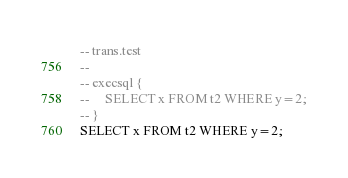<code> <loc_0><loc_0><loc_500><loc_500><_SQL_>-- trans.test
-- 
-- execsql {
--     SELECT x FROM t2 WHERE y=2;
-- }
SELECT x FROM t2 WHERE y=2;</code> 